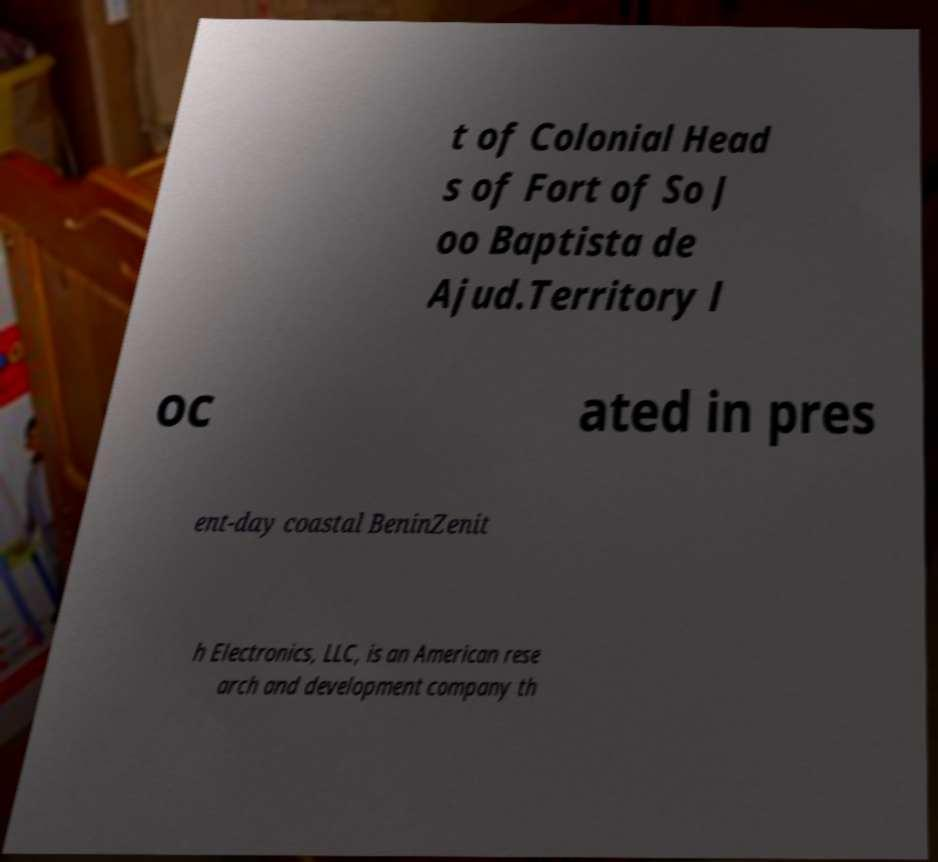Could you assist in decoding the text presented in this image and type it out clearly? t of Colonial Head s of Fort of So J oo Baptista de Ajud.Territory l oc ated in pres ent-day coastal BeninZenit h Electronics, LLC, is an American rese arch and development company th 